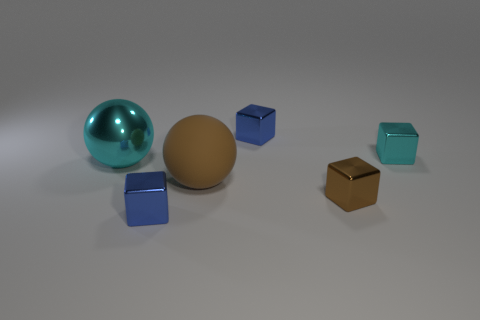Does the tiny metallic thing that is in front of the brown shiny block have the same shape as the tiny blue metal thing that is to the right of the brown sphere?
Make the answer very short. Yes. There is a thing that is the same size as the cyan sphere; what shape is it?
Provide a short and direct response. Sphere. Are the small cube in front of the brown block and the thing that is to the right of the tiny brown metallic object made of the same material?
Offer a very short reply. Yes. There is a small blue thing behind the big cyan sphere; are there any large cyan metal objects that are behind it?
Keep it short and to the point. No. What is the color of the large sphere that is made of the same material as the tiny cyan thing?
Give a very brief answer. Cyan. Are there more big blue shiny objects than tiny brown shiny blocks?
Provide a succinct answer. No. How many things are either small blue shiny blocks that are to the left of the brown rubber ball or green matte spheres?
Give a very brief answer. 1. Is there a cyan metal ball of the same size as the brown rubber sphere?
Give a very brief answer. Yes. Are there fewer shiny cubes than brown shiny things?
Make the answer very short. No. How many spheres are cyan things or small things?
Give a very brief answer. 1. 